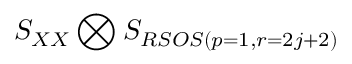Convert formula to latex. <formula><loc_0><loc_0><loc_500><loc_500>S _ { X X } \bigotimes S _ { R S O S ( p = 1 , r = 2 j + 2 ) }</formula> 